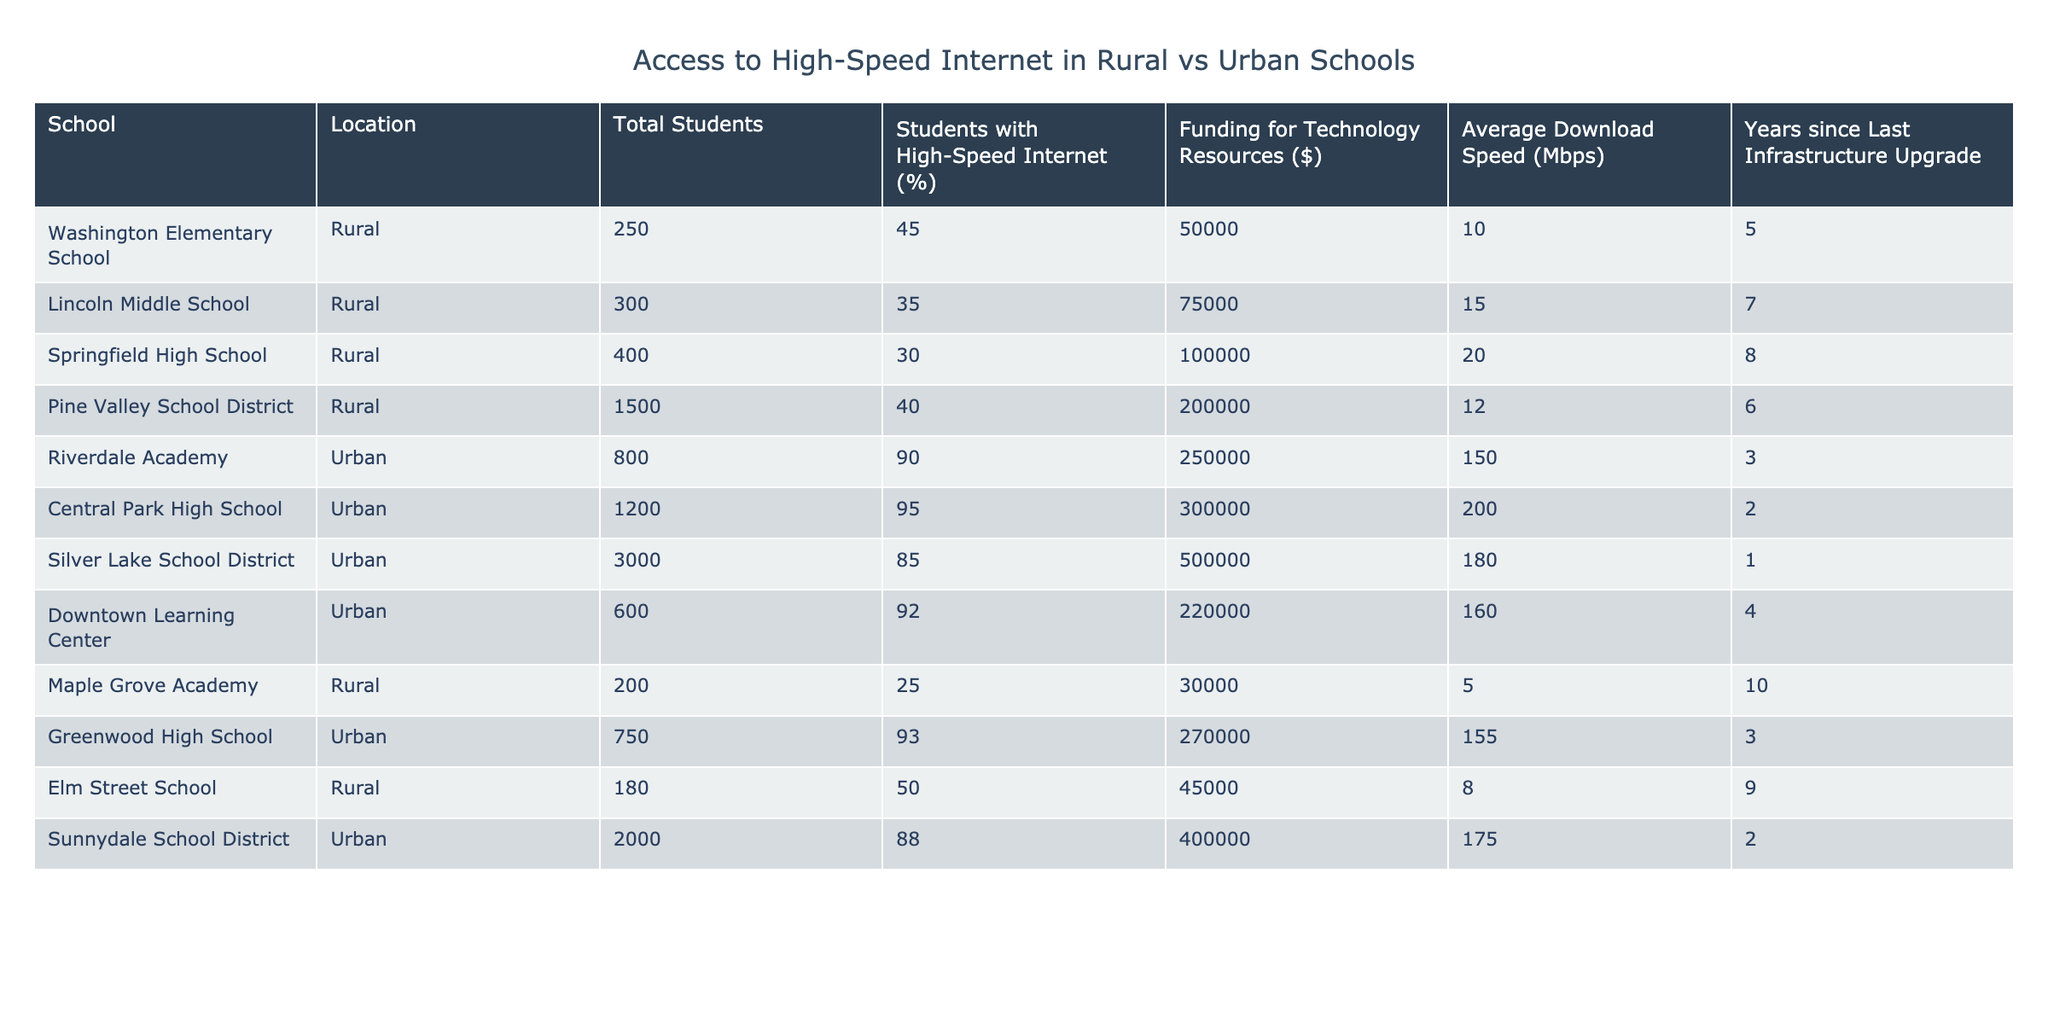What percentage of students at Pine Valley School District have access to high-speed internet? Referring to the table, Pine Valley School District has 40% of its students with access to high-speed internet.
Answer: 40% What is the average funding for technology resources in urban schools? The urban schools listed are Riverdale Academy, Central Park High School, Silver Lake School District, Downtown Learning Center, and Greenwood High School. Their total funding is $250,000 + $300,000 + $500,000 + $220,000 + $270,000 = $1,540,000. There are 5 urban schools, so the average is $1,540,000 / 5 = $308,000.
Answer: $308,000 How many students at Springfield High School lack access to high-speed internet? Springfield High School has 400 total students and 30% with high-speed internet. Therefore, the number of students who lack access is 400 - (400 * 0.30) = 400 - 120 = 280.
Answer: 280 Is the average download speed higher in urban or rural schools? The average download speed for urban schools is (150 + 200 + 180 + 160 + 155) / 5 = 169 Mbps. The average for rural schools is (10 + 15 + 20 + 12 + 5 + 50) / 6 = 18.67 Mbps. Since 169 > 18.67, the average download speed is higher in urban schools.
Answer: Yes What is the total number of students across all rural schools listed? The total number of students at the rural schools is 250 + 300 + 400 + 1500 + 200 + 180 = 2880 students.
Answer: 2880 Which urban school has the highest average download speed? Checking the average download speeds, Riverdale Academy has 150 Mbps, Central Park High School has 200 Mbps, Silver Lake School District has 180 Mbps, Downtown Learning Center has 160 Mbps, and Greenwood High School has 155 Mbps. Thus, Central Park High School has the highest average at 200 Mbps.
Answer: Central Park High School How many years since the last infrastructure upgrade does Silver Lake School District have? Silver Lake School District's table entry states "1" year since the last infrastructure upgrade.
Answer: 1 Which group of schools (rural or urban) has a higher average percentage of students with high-speed internet? The percentage of students with high-speed internet for rural schools averages (45 + 35 + 30 + 40 + 25 + 50) / 6 = 37.50%, while for urban schools, it averages (90 + 95 + 85 + 92 + 93) / 5 = 91%. Since 91% > 37.50%, urban schools have a higher average.
Answer: Urban schools What is the difference in funding for technology resources between the highest rural school and the highest urban school? The highest funding for rural schools is $100,000 (Springfield High School), and the highest for urban schools is $500,000 (Silver Lake School District). Therefore, the difference is $500,000 - $100,000 = $400,000.
Answer: $400,000 Are there any urban schools with more than 2,000 students? Reviewing the table, Sunnydale School District has 2,000 students, and Silver Lake School District has 3,000. Therefore, there are urban schools with more than 2,000 students.
Answer: Yes 